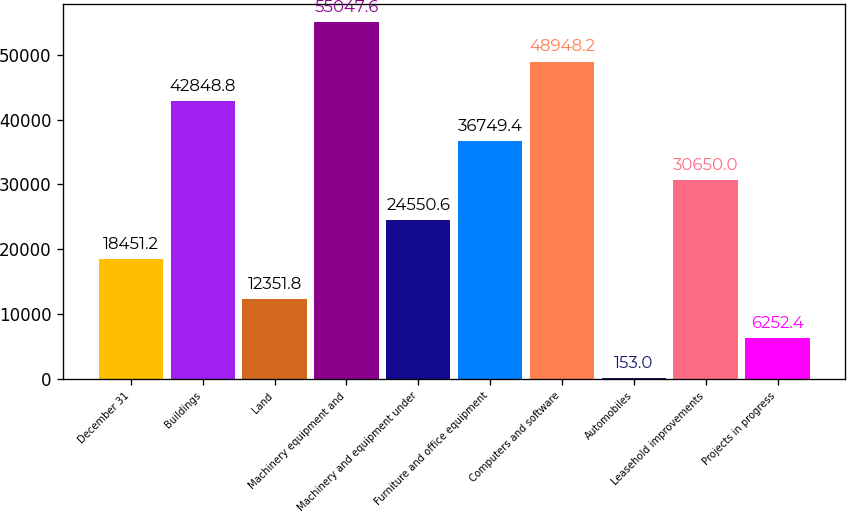Convert chart. <chart><loc_0><loc_0><loc_500><loc_500><bar_chart><fcel>December 31<fcel>Buildings<fcel>Land<fcel>Machinery equipment and<fcel>Machinery and equipment under<fcel>Furniture and office equipment<fcel>Computers and software<fcel>Automobiles<fcel>Leasehold improvements<fcel>Projects in progress<nl><fcel>18451.2<fcel>42848.8<fcel>12351.8<fcel>55047.6<fcel>24550.6<fcel>36749.4<fcel>48948.2<fcel>153<fcel>30650<fcel>6252.4<nl></chart> 